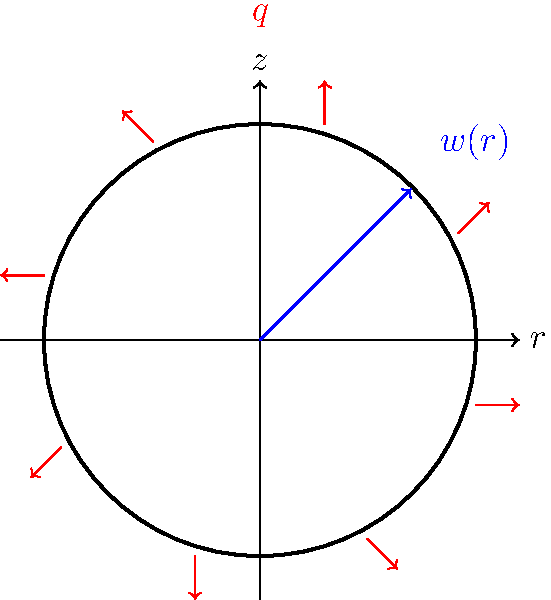In the context of translating ancient Islamic texts on mechanics, you encounter a problem discussing the deformation of a circular plate under uniform pressure. The plate has a radius $a$, thickness $h$, Young's modulus $E$, and Poisson's ratio $\nu$. It is subjected to a uniform pressure $q$. What is the maximum deflection $w_max$ at the center of the plate, assuming small deflections and that the edge of the plate is simply supported? To solve this problem, we'll follow these steps:

1. Recall the general equation for the deflection of a circular plate under uniform pressure:

   $$w(r) = \frac{q}{64D}(a^2-r^2)(5+\nu)(a^2-r^2)$$

   Where $D$ is the flexural rigidity given by:
   
   $$D = \frac{Eh^3}{12(1-\nu^2)}$$

2. The maximum deflection occurs at the center of the plate where $r=0$. Substituting this into the general equation:

   $$w_{max} = w(0) = \frac{q}{64D}(a^2)(5+\nu)(a^2)$$

3. Simplify:

   $$w_{max} = \frac{q a^4 (5+\nu)}{64D}$$

4. Substitute the expression for $D$:

   $$w_{max} = \frac{q a^4 (5+\nu)}{64 \cdot \frac{Eh^3}{12(1-\nu^2)}}$$

5. Simplify further:

   $$w_{max} = \frac{3q a^4 (5+\nu)(1-\nu^2)}{16Eh^3}$$

This final equation gives the maximum deflection at the center of the simply supported circular plate under uniform pressure.
Answer: $w_{max} = \frac{3q a^4 (5+\nu)(1-\nu^2)}{16Eh^3}$ 